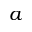<formula> <loc_0><loc_0><loc_500><loc_500>a</formula> 